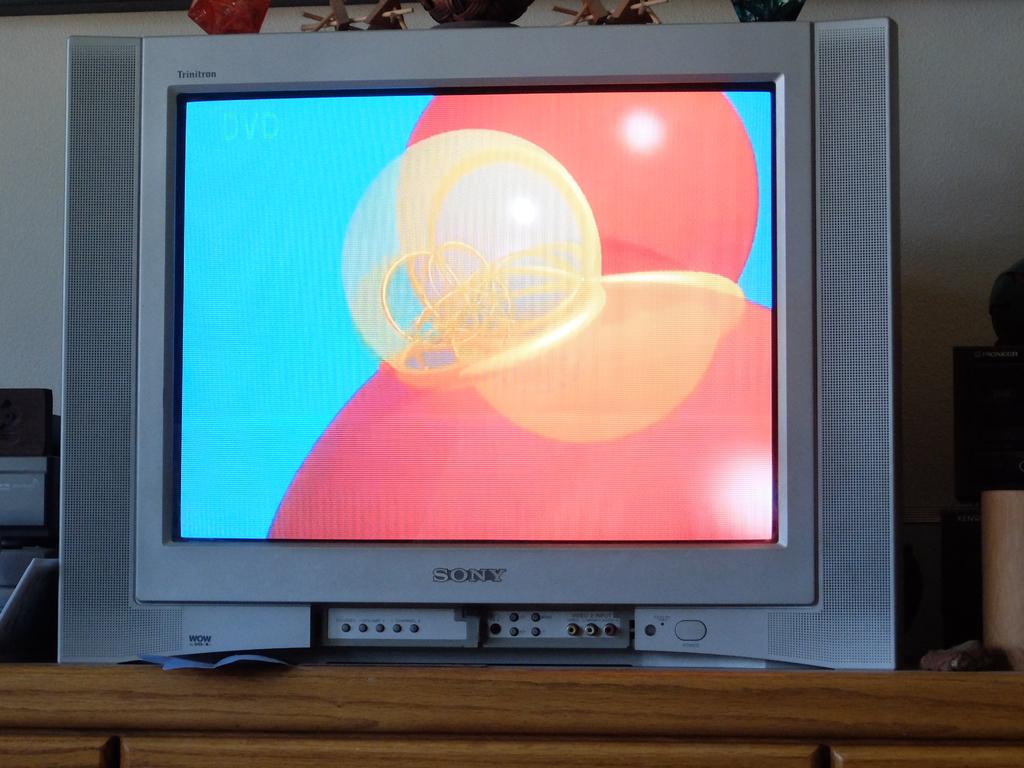What is the tv brand seen here?
Your answer should be very brief. Sony. 